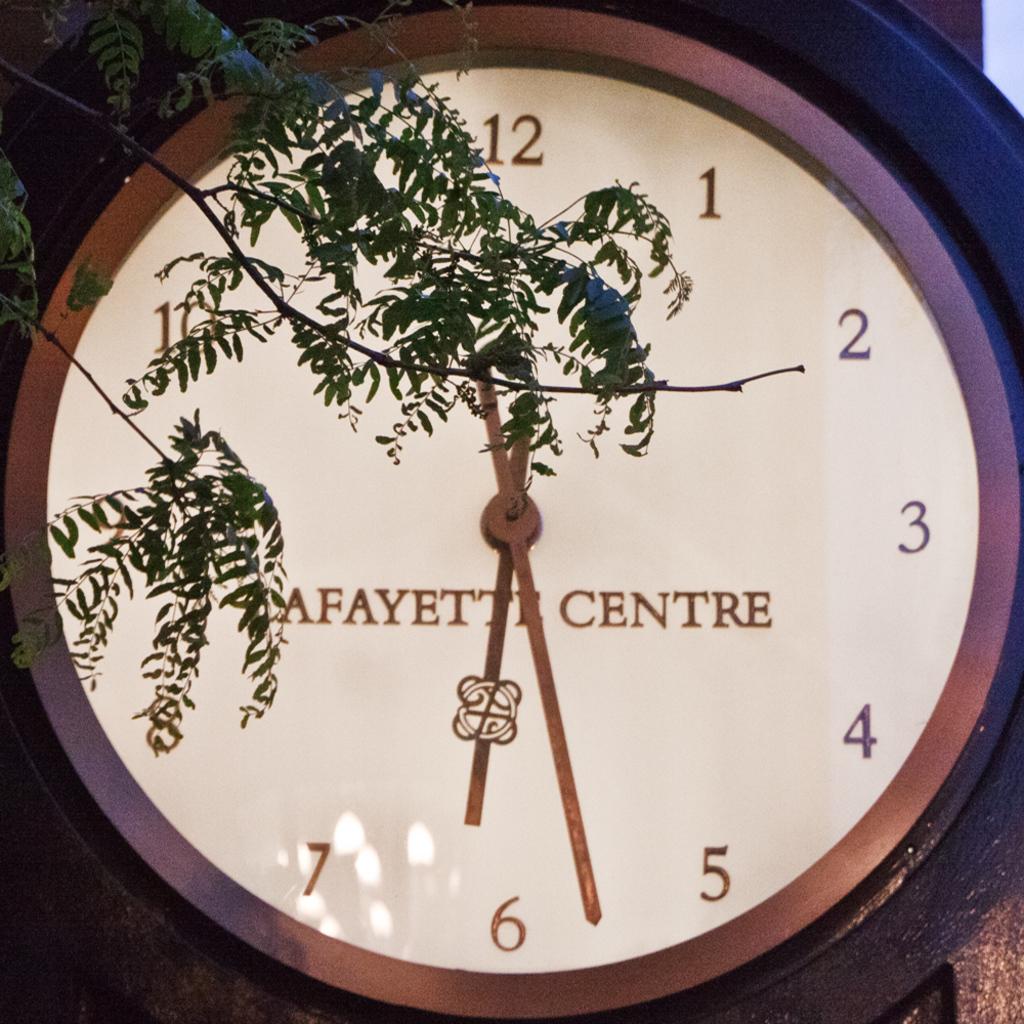What time is the clock saying?
Your response must be concise. 6:28. 